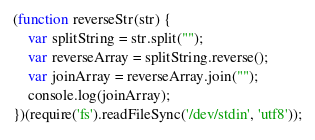Convert code to text. <code><loc_0><loc_0><loc_500><loc_500><_JavaScript_>(function reverseStr(str) {
    var splitString = str.split("");  
    var reverseArray = splitString.reverse(); 
    var joinArray = reverseArray.join("");     
    console.log(joinArray);
})(require('fs').readFileSync('/dev/stdin', 'utf8'));</code> 